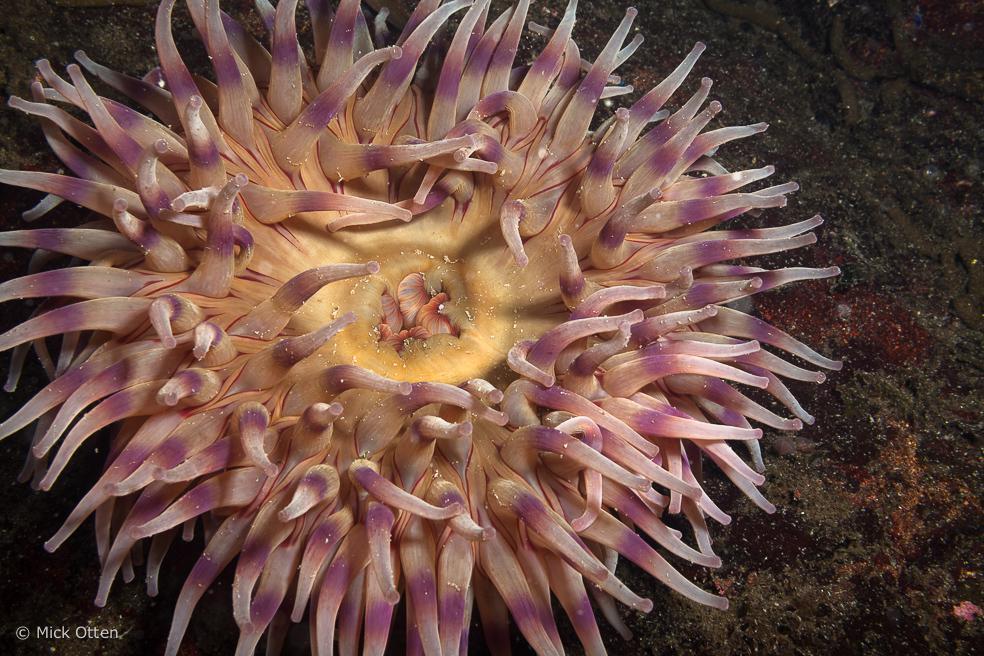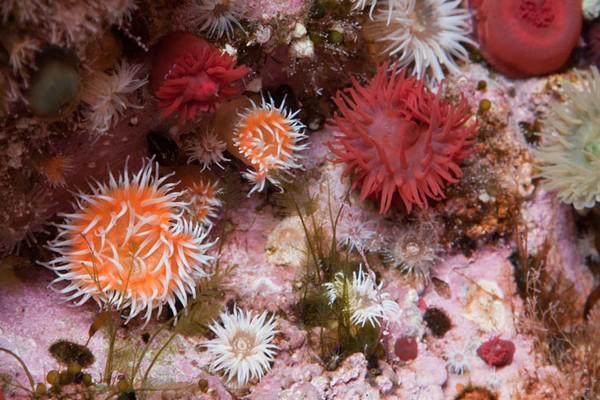The first image is the image on the left, the second image is the image on the right. For the images displayed, is the sentence "At least one image features several anemone." factually correct? Answer yes or no. Yes. 